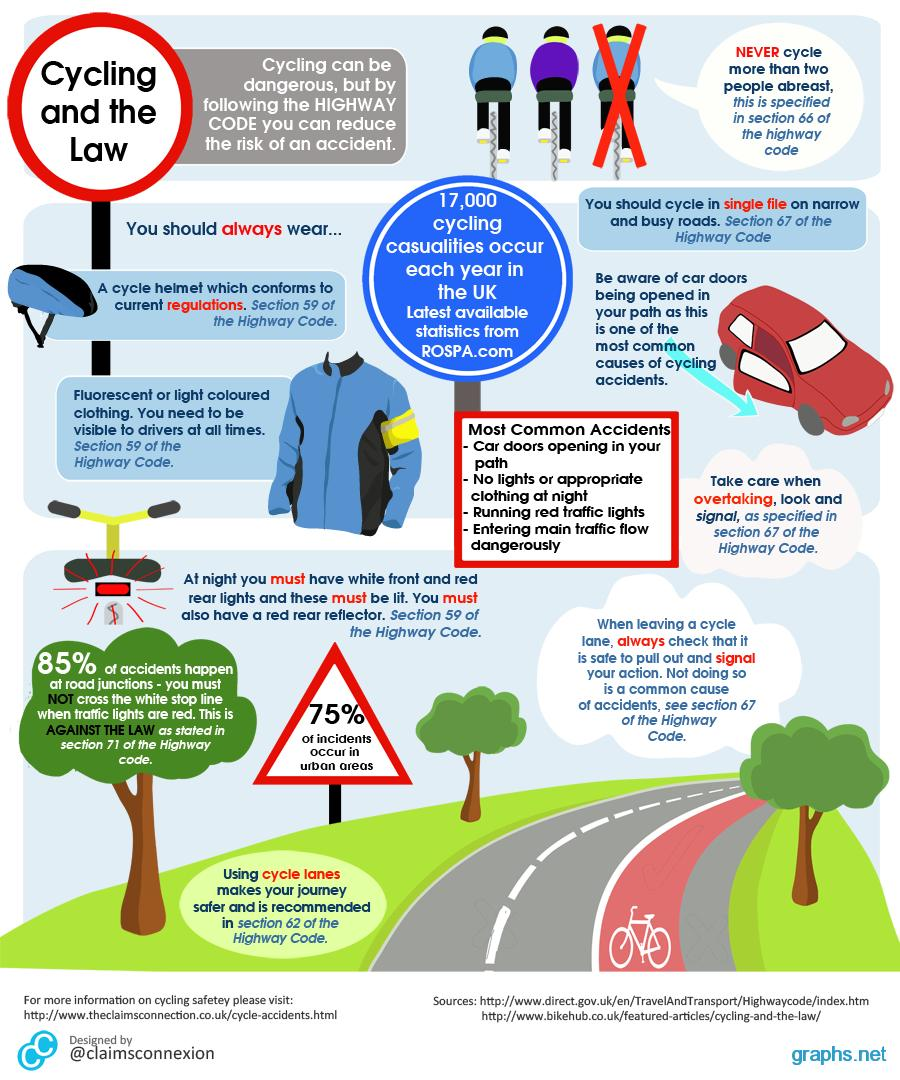List a handful of essential elements in this visual. The heading "Most Common Accidents" contains four points. There are three trees depicted in this infographic. The color of the car is red. According to statistics, 15% of accidents occur in other parts of the road. Approximately 25% of accidents occur in areas that are not urban. 